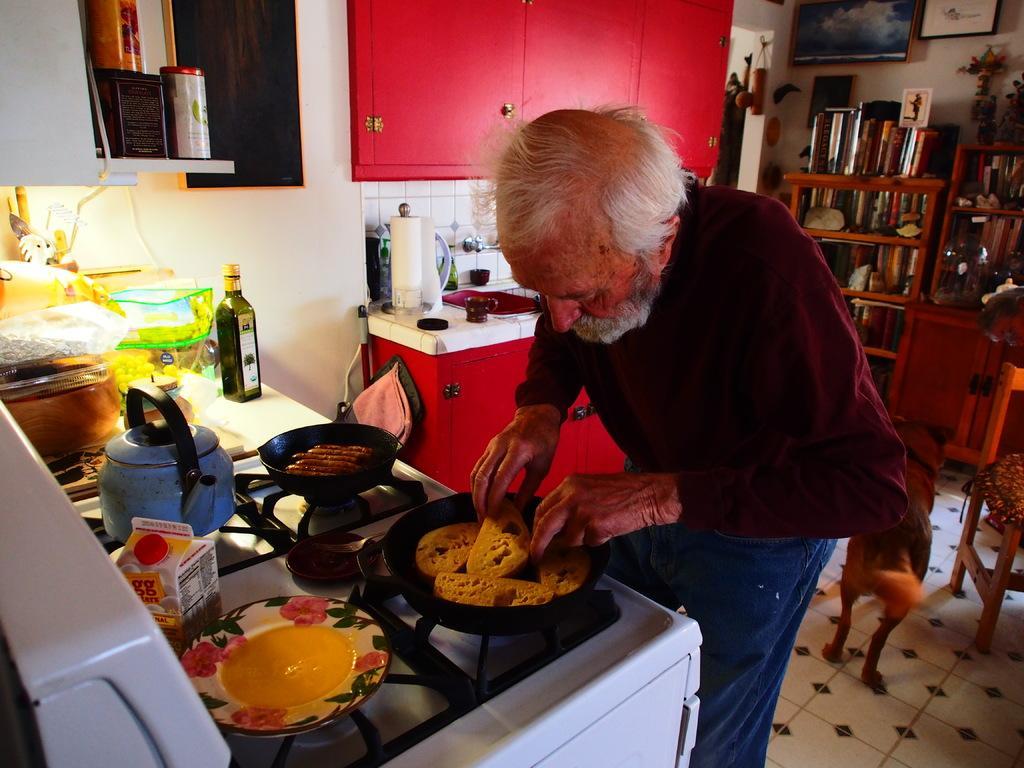Could you give a brief overview of what you see in this image? This seems to be a kitchen. An old man is preparing food. I can see some objects on the kitchen platform with the stove and there is a wooden cupboard with some objects. 